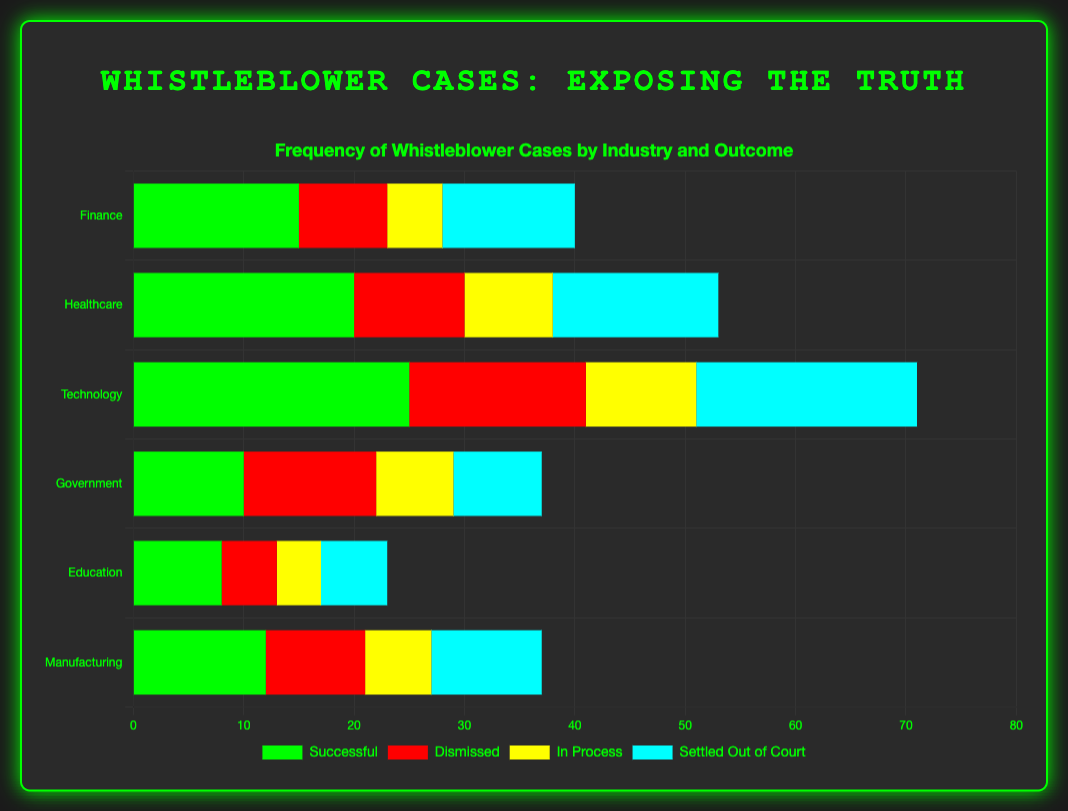Which industry has the highest frequency of successful whistleblower cases? The industry with the highest frequency of successful whistleblower cases is determined by identifying the highest bar in the "Successful" category. Technology has the highest bar with a frequency of 25.
Answer: Technology What is the combined total of dismissed and settled out of court cases in the Healthcare industry? Add the frequency of dismissed cases (10) and settled out of court cases (15) in the Healthcare industry. 10 + 15 = 25
Answer: 25 In which industry is the number of in-process cases greater than the number of dismissed cases? Compare the in-process and dismissed frequencies across industries. In Technology, the number of in-process cases (10) is less than dismissed cases (16). Continue this process. Only in Government, the in-process cases (7) is less than the dismissed cases (12). So, no such industry exists.
Answer: None Which two outcomes have the same frequency in the Education industry? Identify the frequencies for each outcome in the Education industry: Successful (8), Dismissed (5), In Process (4), Settled Out of Court (6). There are no two frequencies that are the same.
Answer: None What is the average number of settled out of court cases across all industries? Sum the frequencies of settled out of court cases across all industries (12 + 15 + 20 + 8 + 6 + 10), then divide by the number of industries (6). (12 + 15 + 20 + 8 + 6 + 10) / 6 = 71 / 6 ≈ 11.83
Answer: 11.83 Which outcome has the highest frequency across all industries? Combine the frequencies of each outcome across all industries: Successful (90), Dismissed (60), In Process (40), Settled Out of Court (71). Successful cases have the highest total frequency of 90.
Answer: Successful Is the number of settled out of court cases in the Manufacturing industry greater than the number of dismissed cases in the Finance industry? Compare the number of settled out of court cases in Manufacturing (10) with the number of dismissed cases in Finance (8). 10 > 8
Answer: Yes What is the ratio of successful cases to dismissed cases in the Technology industry? Find the frequencies of successful (25) and dismissed (16) cases in the Technology industry, then form the ratio: 25/16 = 1.5625
Answer: 1.5625 